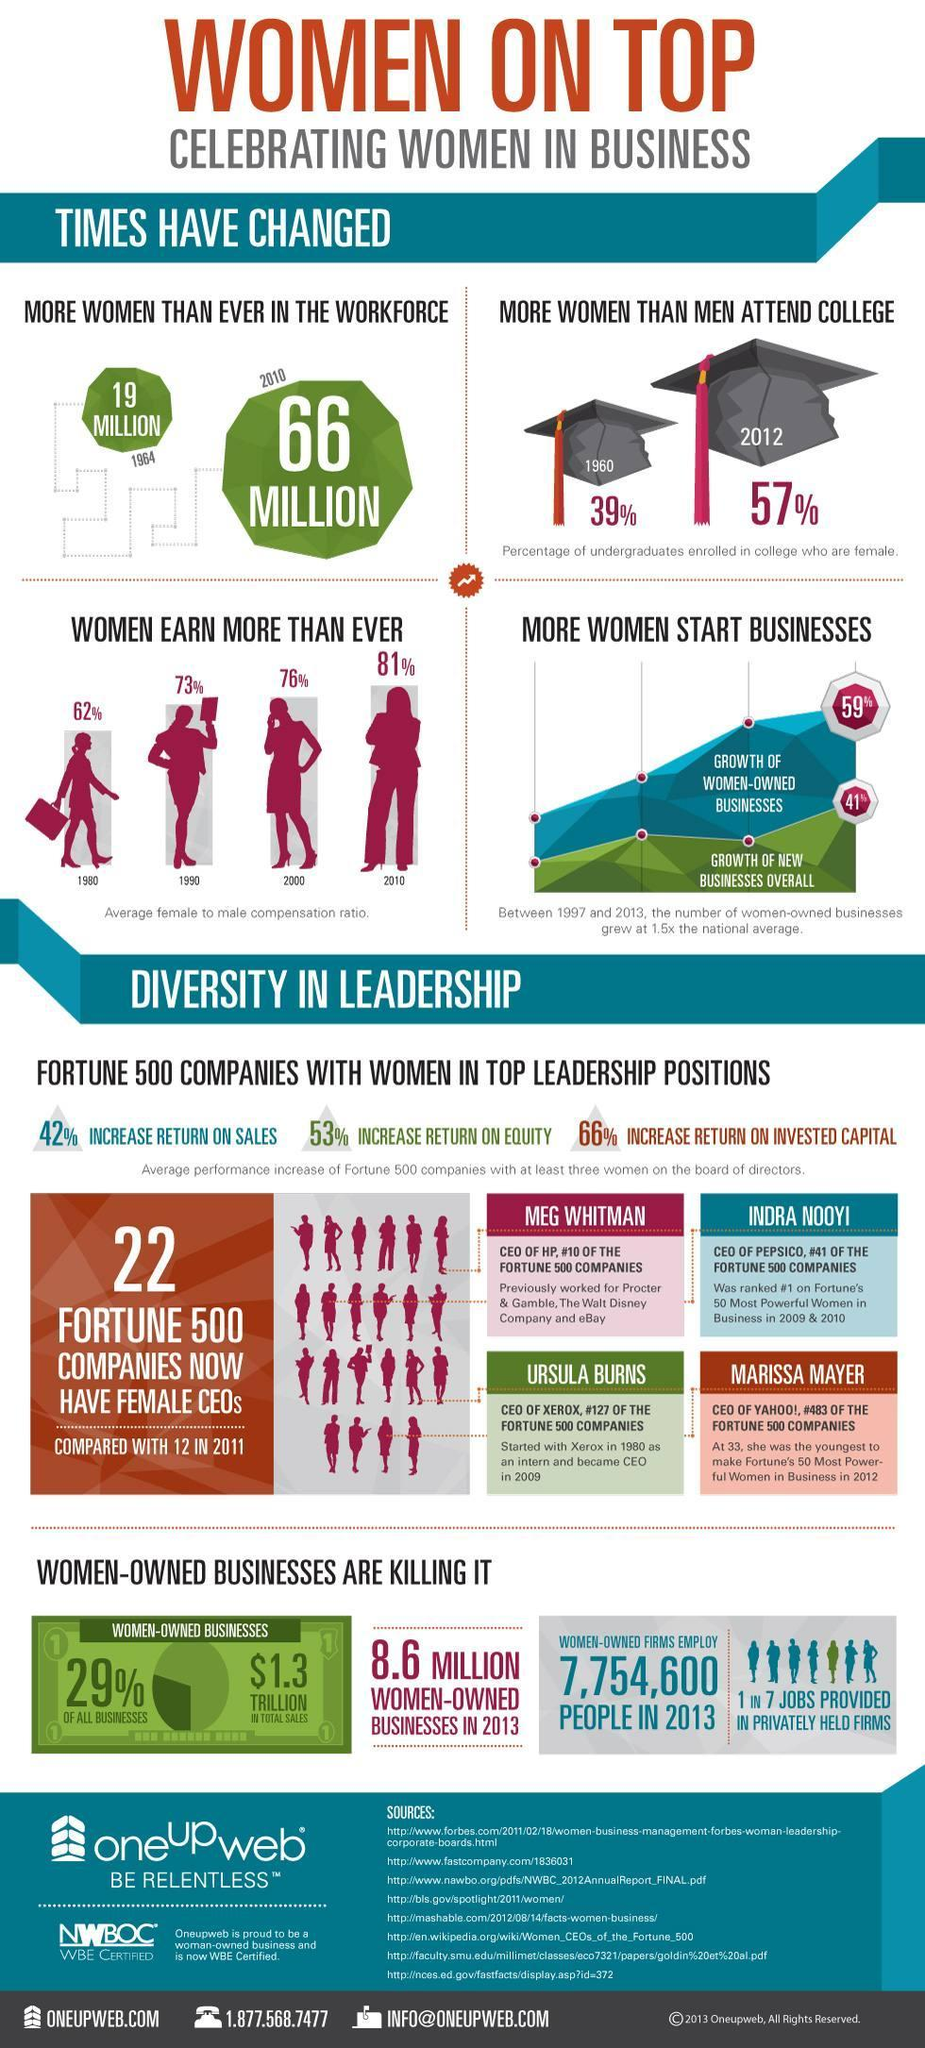what is the increase in female CEOs count in fortune 500 companies when compared to the count in 2011
Answer the question with a short phrase. 10 What is the total sales in women-owned businesses $1.3 trillion How many businesses were women owned in 2013 8.6 million What has been the increase in million in women in workforce from 1964 to 2010 47 In the graph representing business growth, what does the green graph represent growth of new businesses overall 1 in 7 jobs provided in privately held firms are done my whom women In the graph representing business growth, what does the blue graph represent growth of women-owned businesses What is the increase in % of women in college from 1960 to 2012 18 